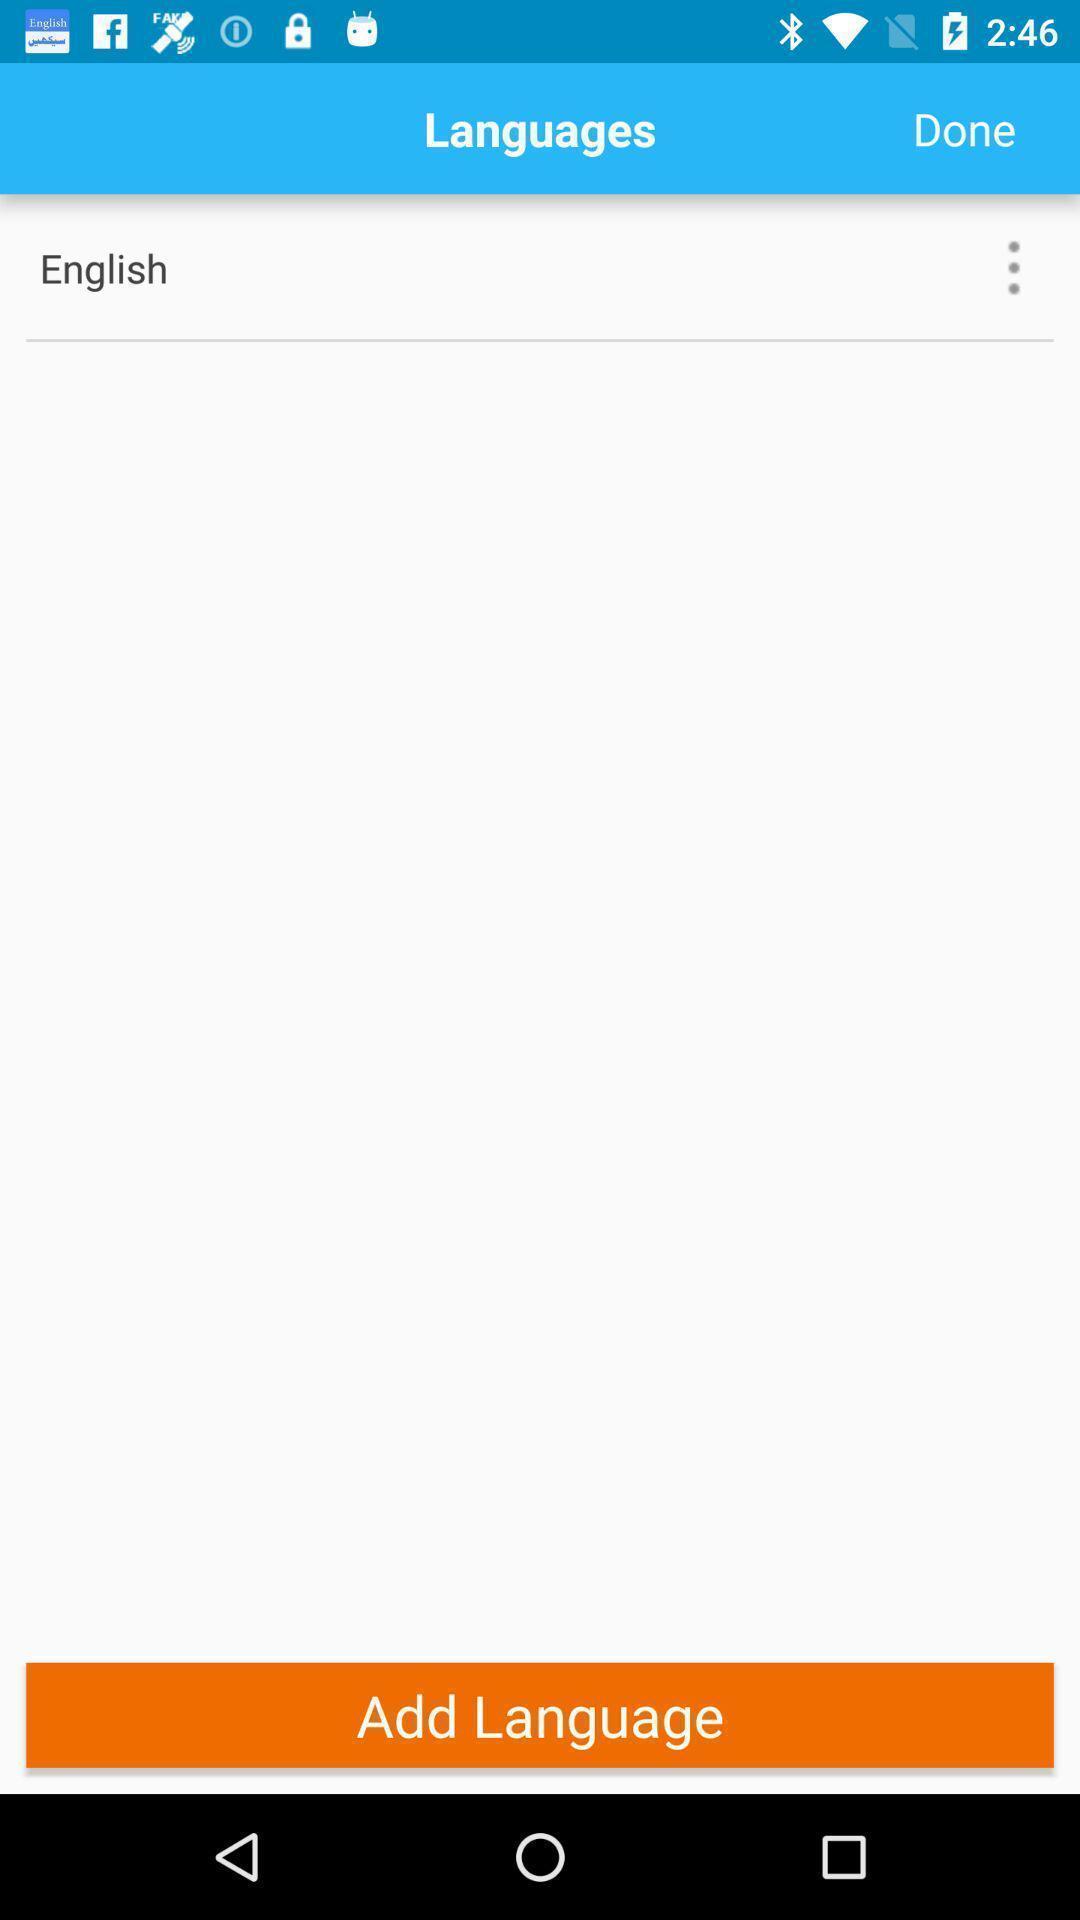Summarize the information in this screenshot. Screen displaying to add language. 